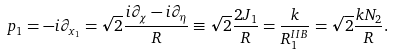Convert formula to latex. <formula><loc_0><loc_0><loc_500><loc_500>p _ { 1 } = - i \partial _ { x _ { 1 } } = \sqrt { 2 } \frac { i \partial _ { \chi } - i \partial _ { \eta } } { R } \equiv \sqrt { 2 } \frac { 2 J _ { 1 } } { R } = \frac { k } { R _ { 1 } ^ { I I B } } = \sqrt { 2 } \frac { k N _ { 2 } } { R } .</formula> 